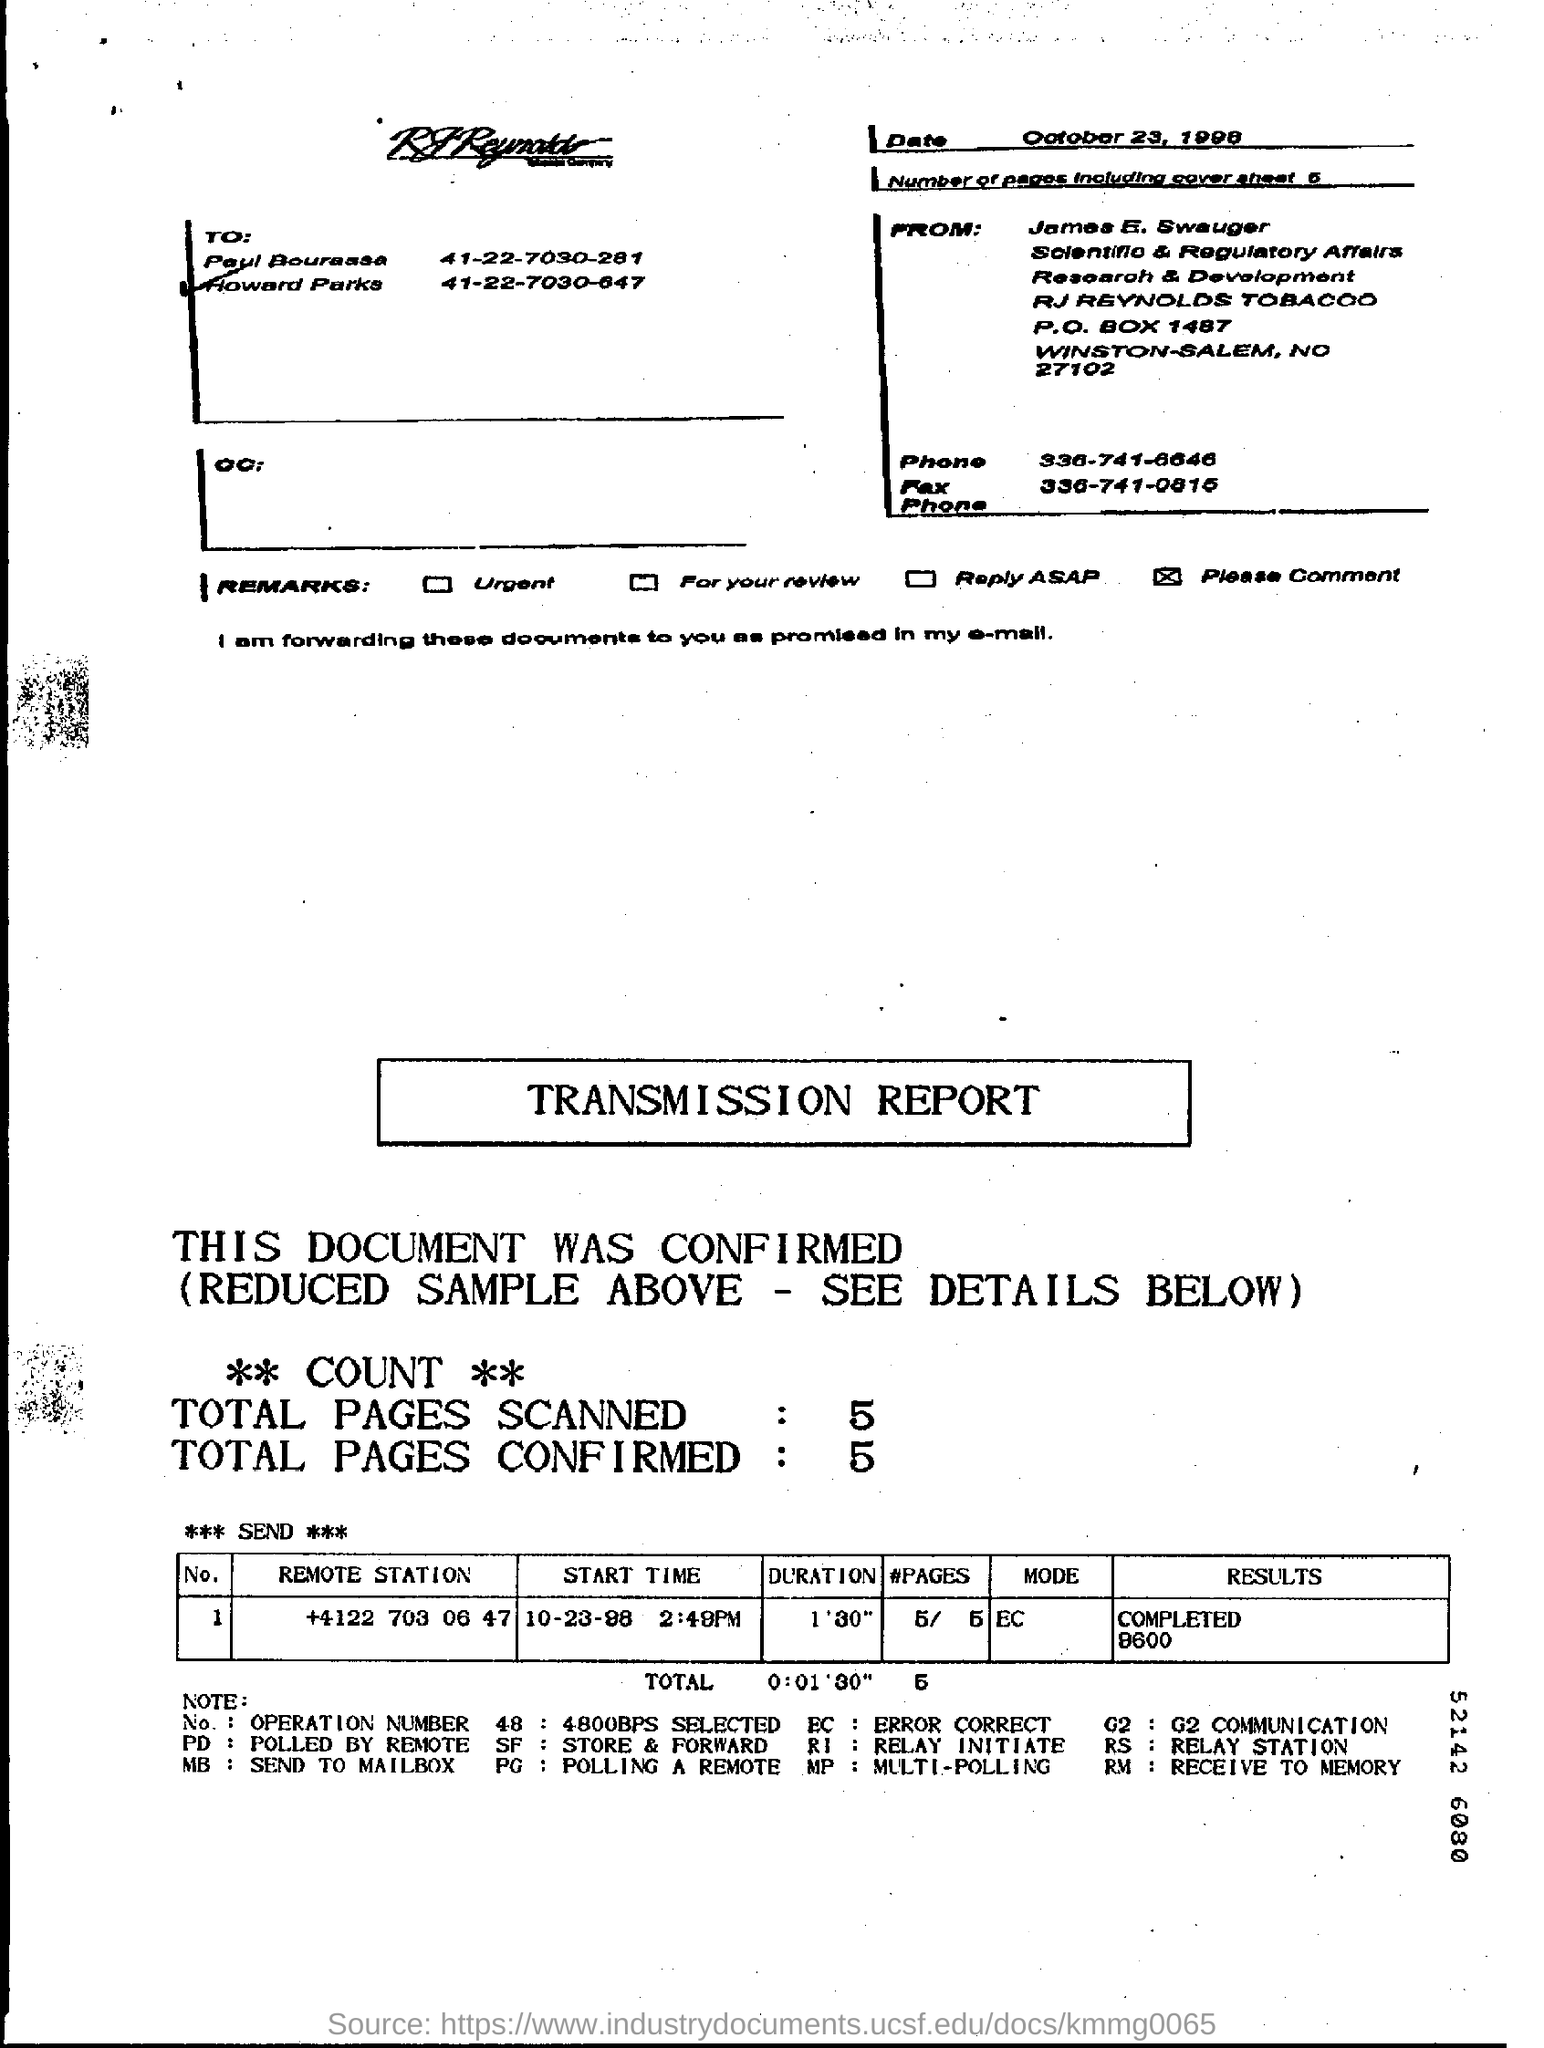Specify some key components in this picture. There are five pages in total, including the cover sheet, in the fax. The fax was sent on October 23, 1998. The transmission report indicates that the total duration is 1 minute and 30 seconds. The fax phone number of James E. Swauger is 336-741-0815. The sender of the fax is James E. Swauger. 